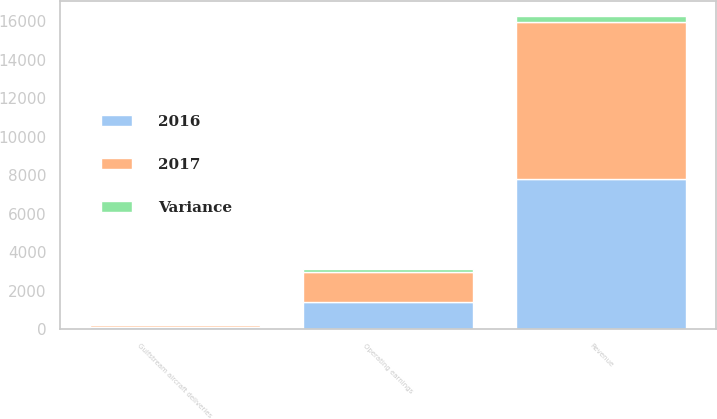<chart> <loc_0><loc_0><loc_500><loc_500><stacked_bar_chart><ecel><fcel>Revenue<fcel>Operating earnings<fcel>Gulfstream aircraft deliveries<nl><fcel>2017<fcel>8129<fcel>1577<fcel>120<nl><fcel>2016<fcel>7815<fcel>1394<fcel>121<nl><fcel>Variance<fcel>314<fcel>183<fcel>1<nl></chart> 